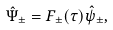Convert formula to latex. <formula><loc_0><loc_0><loc_500><loc_500>\hat { \Psi } _ { \pm } = F _ { \pm } ( \tau ) \hat { \psi } _ { \pm } ,</formula> 